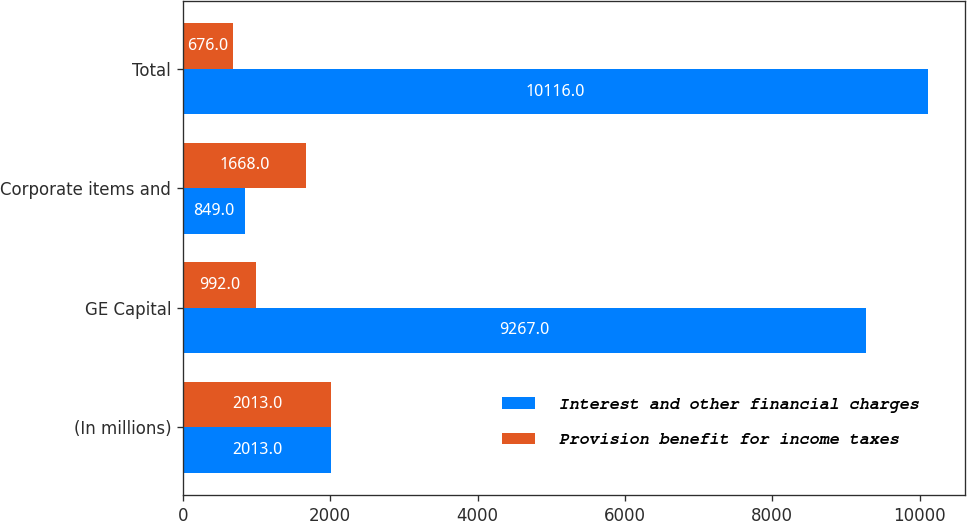<chart> <loc_0><loc_0><loc_500><loc_500><stacked_bar_chart><ecel><fcel>(In millions)<fcel>GE Capital<fcel>Corporate items and<fcel>Total<nl><fcel>Interest and other financial charges<fcel>2013<fcel>9267<fcel>849<fcel>10116<nl><fcel>Provision benefit for income taxes<fcel>2013<fcel>992<fcel>1668<fcel>676<nl></chart> 